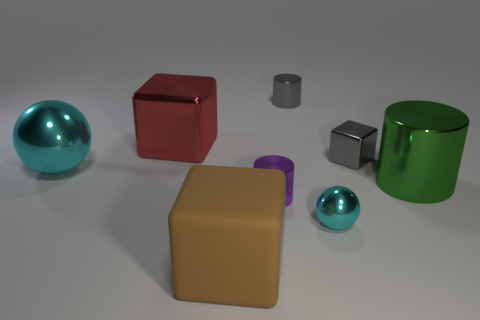Can you tell me how many objects are depicted and what shapes they are? Certainly! The image depicts seven objects. There are two spheres, two cubes, one cylinder, one cuboid, and one truncated cone. Each has a distinct color, varying in shades of blue, red, purple, green, and gray. 